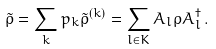Convert formula to latex. <formula><loc_0><loc_0><loc_500><loc_500>\tilde { \rho } = \sum _ { k } p _ { k } \tilde { \rho } ^ { ( k ) } = \sum _ { l \in K } A _ { l } \rho A ^ { \dagger } _ { l } \, .</formula> 